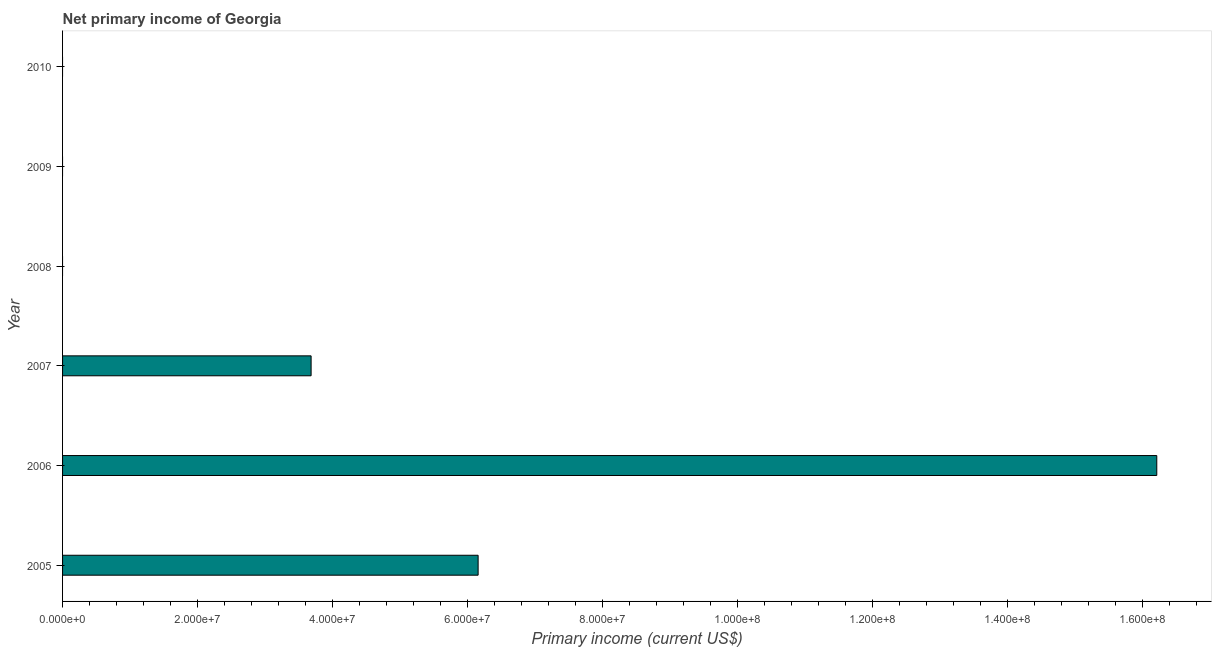What is the title of the graph?
Give a very brief answer. Net primary income of Georgia. What is the label or title of the X-axis?
Ensure brevity in your answer.  Primary income (current US$). What is the label or title of the Y-axis?
Offer a very short reply. Year. Across all years, what is the maximum amount of primary income?
Offer a terse response. 1.62e+08. Across all years, what is the minimum amount of primary income?
Offer a very short reply. 0. In which year was the amount of primary income maximum?
Offer a terse response. 2006. What is the sum of the amount of primary income?
Offer a terse response. 2.60e+08. What is the difference between the amount of primary income in 2006 and 2007?
Offer a terse response. 1.25e+08. What is the average amount of primary income per year?
Your answer should be compact. 4.34e+07. What is the median amount of primary income?
Your response must be concise. 1.84e+07. What is the difference between the highest and the second highest amount of primary income?
Offer a very short reply. 1.01e+08. What is the difference between the highest and the lowest amount of primary income?
Offer a very short reply. 1.62e+08. In how many years, is the amount of primary income greater than the average amount of primary income taken over all years?
Keep it short and to the point. 2. How many bars are there?
Keep it short and to the point. 3. Are all the bars in the graph horizontal?
Provide a short and direct response. Yes. Are the values on the major ticks of X-axis written in scientific E-notation?
Give a very brief answer. Yes. What is the Primary income (current US$) of 2005?
Provide a succinct answer. 6.16e+07. What is the Primary income (current US$) in 2006?
Ensure brevity in your answer.  1.62e+08. What is the Primary income (current US$) of 2007?
Give a very brief answer. 3.68e+07. What is the Primary income (current US$) of 2008?
Your answer should be very brief. 0. What is the Primary income (current US$) in 2010?
Ensure brevity in your answer.  0. What is the difference between the Primary income (current US$) in 2005 and 2006?
Offer a very short reply. -1.01e+08. What is the difference between the Primary income (current US$) in 2005 and 2007?
Your response must be concise. 2.47e+07. What is the difference between the Primary income (current US$) in 2006 and 2007?
Your answer should be compact. 1.25e+08. What is the ratio of the Primary income (current US$) in 2005 to that in 2006?
Make the answer very short. 0.38. What is the ratio of the Primary income (current US$) in 2005 to that in 2007?
Your answer should be compact. 1.67. What is the ratio of the Primary income (current US$) in 2006 to that in 2007?
Keep it short and to the point. 4.4. 